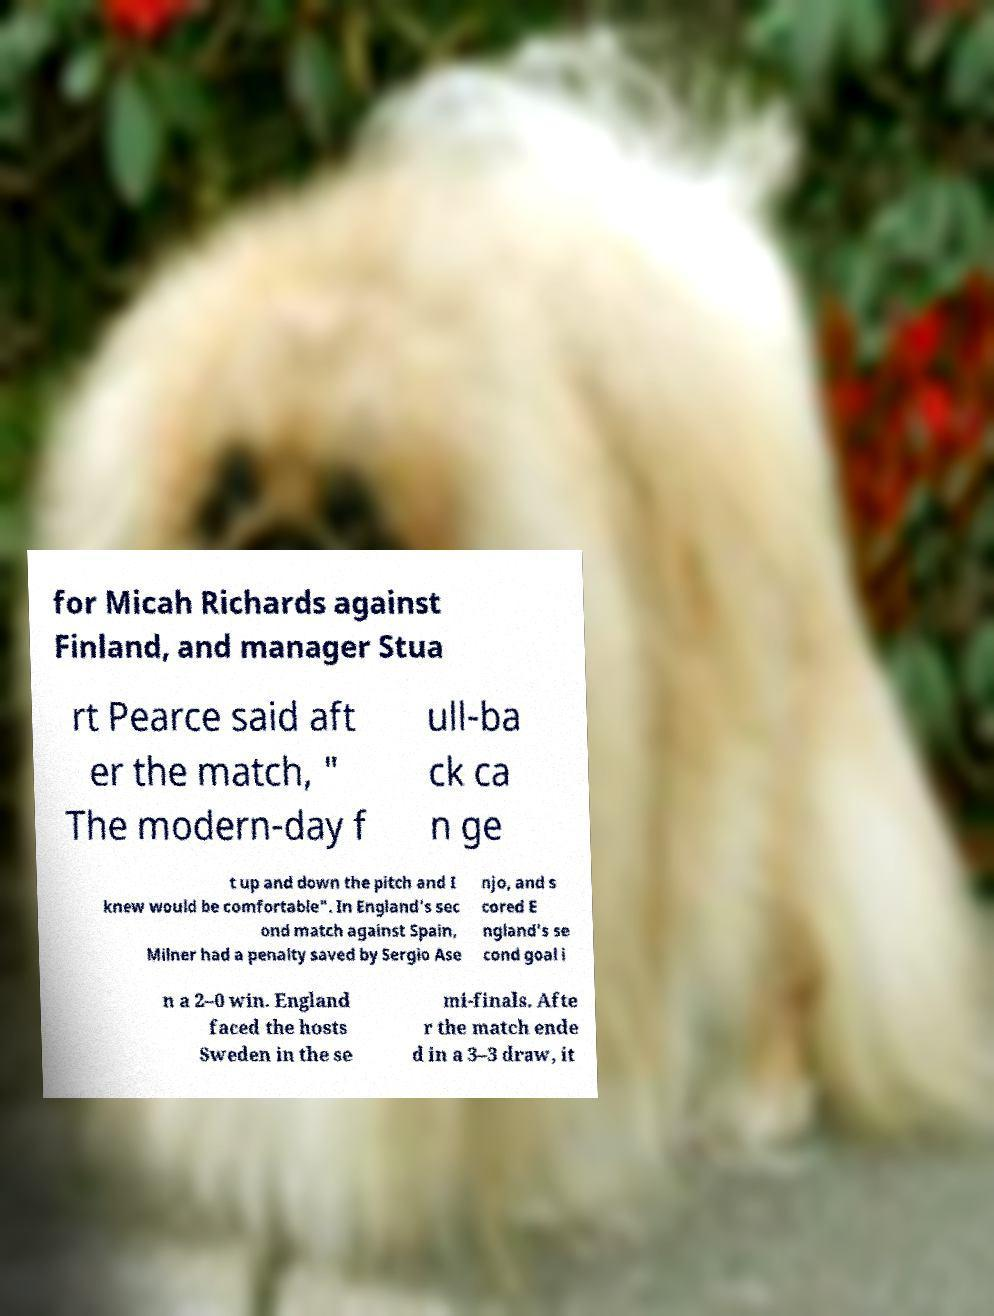Could you extract and type out the text from this image? for Micah Richards against Finland, and manager Stua rt Pearce said aft er the match, " The modern-day f ull-ba ck ca n ge t up and down the pitch and I knew would be comfortable". In England's sec ond match against Spain, Milner had a penalty saved by Sergio Ase njo, and s cored E ngland's se cond goal i n a 2–0 win. England faced the hosts Sweden in the se mi-finals. Afte r the match ende d in a 3–3 draw, it 